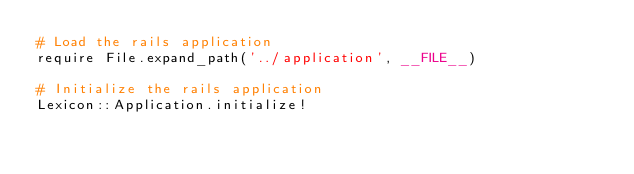Convert code to text. <code><loc_0><loc_0><loc_500><loc_500><_Ruby_># Load the rails application
require File.expand_path('../application', __FILE__)

# Initialize the rails application
Lexicon::Application.initialize!
</code> 